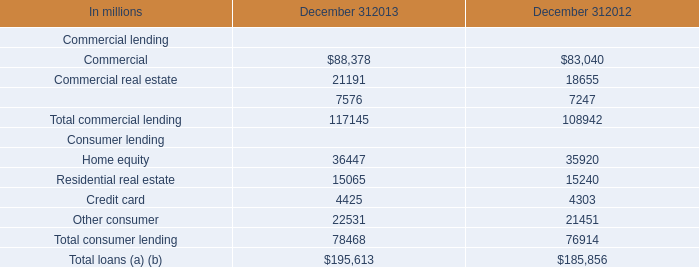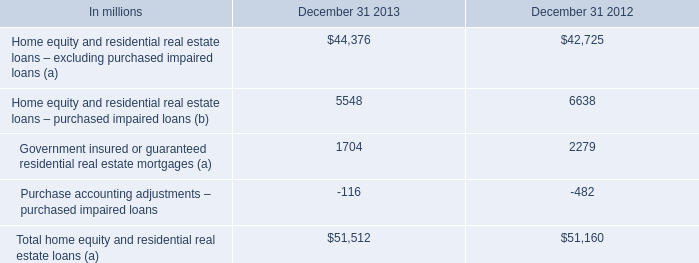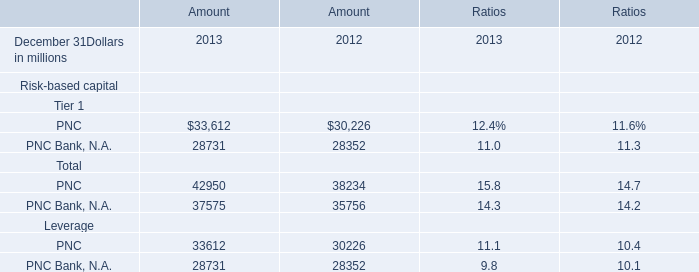What is the sum of PNC of Amount 2012, and Home equity Consumer lending of December 312013 ? 
Computations: (30226.0 + 36447.0)
Answer: 66673.0. 